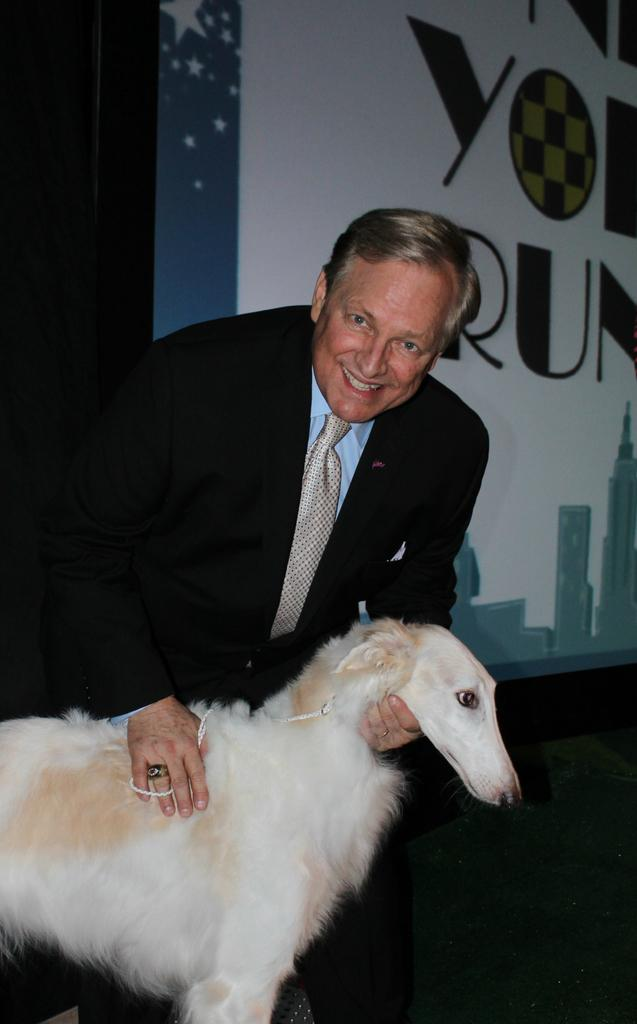Who is the main subject in the image? There is a man in the image. What is the man doing in the image? The man is holding a dog. What is the man wearing in the image? The man is wearing a black suit. What is the man's facial expression in the image? The man is smiling. What type of fiction is the man reading in the image? There is no book or any form of fiction present in the image. 